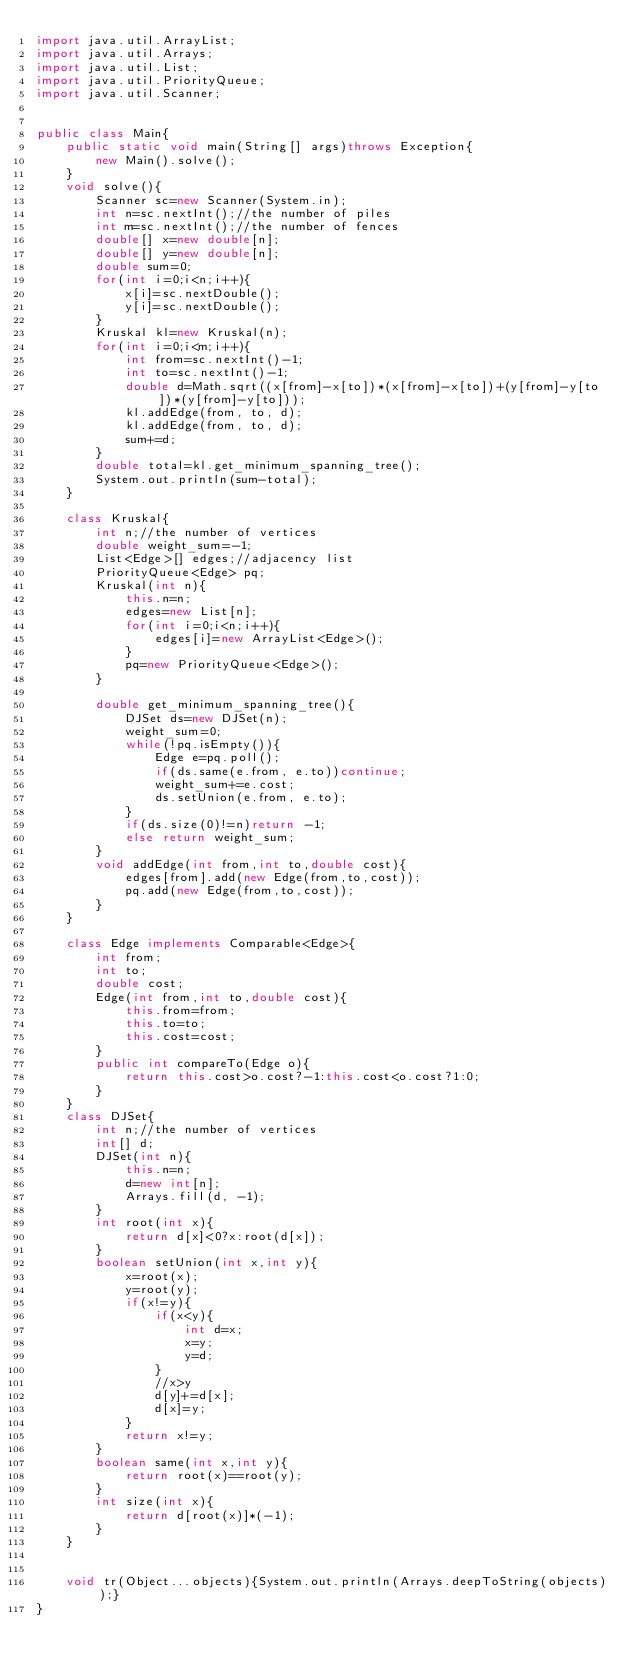<code> <loc_0><loc_0><loc_500><loc_500><_Java_>import java.util.ArrayList;
import java.util.Arrays;
import java.util.List;
import java.util.PriorityQueue;
import java.util.Scanner;


public class Main{
	public static void main(String[] args)throws Exception{
		new Main().solve();
	}
	void solve(){
		Scanner sc=new Scanner(System.in);
		int n=sc.nextInt();//the number of piles
		int m=sc.nextInt();//the number of fences
		double[] x=new double[n];
		double[] y=new double[n];
		double sum=0;
		for(int i=0;i<n;i++){
			x[i]=sc.nextDouble();
			y[i]=sc.nextDouble();
		}
		Kruskal kl=new Kruskal(n);
		for(int i=0;i<m;i++){
			int from=sc.nextInt()-1;
			int to=sc.nextInt()-1;
			double d=Math.sqrt((x[from]-x[to])*(x[from]-x[to])+(y[from]-y[to])*(y[from]-y[to]));
			kl.addEdge(from, to, d);
			kl.addEdge(from, to, d);
			sum+=d;
		}
		double total=kl.get_minimum_spanning_tree();
		System.out.println(sum-total);
	}

	class Kruskal{
		int n;//the number of vertices
		double weight_sum=-1;
		List<Edge>[] edges;//adjacency list
		PriorityQueue<Edge> pq;
		Kruskal(int n){
			this.n=n;
			edges=new List[n];
			for(int i=0;i<n;i++){
				edges[i]=new ArrayList<Edge>();
			}
			pq=new PriorityQueue<Edge>();
		}

		double get_minimum_spanning_tree(){
			DJSet ds=new DJSet(n);
			weight_sum=0;
			while(!pq.isEmpty()){
				Edge e=pq.poll();
				if(ds.same(e.from, e.to))continue;
				weight_sum+=e.cost;
				ds.setUnion(e.from, e.to);
			}
			if(ds.size(0)!=n)return -1;
			else return weight_sum;
		}
		void addEdge(int from,int to,double cost){
			edges[from].add(new Edge(from,to,cost));
			pq.add(new Edge(from,to,cost));
		}
	}

	class Edge implements Comparable<Edge>{
		int from;
		int to;
		double cost;
		Edge(int from,int to,double cost){
			this.from=from;
			this.to=to;
			this.cost=cost;
		}
		public int compareTo(Edge o){
			return this.cost>o.cost?-1:this.cost<o.cost?1:0;
		}
	}
	class DJSet{
		int n;//the number of vertices
		int[] d;
		DJSet(int n){
			this.n=n;
			d=new int[n];
			Arrays.fill(d, -1);
		}
		int root(int x){
			return d[x]<0?x:root(d[x]);
		}
		boolean setUnion(int x,int y){
			x=root(x);
			y=root(y);
			if(x!=y){
				if(x<y){
					int d=x;
					x=y;
					y=d;
				}
				//x>y
				d[y]+=d[x];
				d[x]=y;
			}
			return x!=y;
		}
		boolean same(int x,int y){
			return root(x)==root(y);
		}
		int size(int x){
			return d[root(x)]*(-1);
		}
	}


	void tr(Object...objects){System.out.println(Arrays.deepToString(objects));}
}</code> 